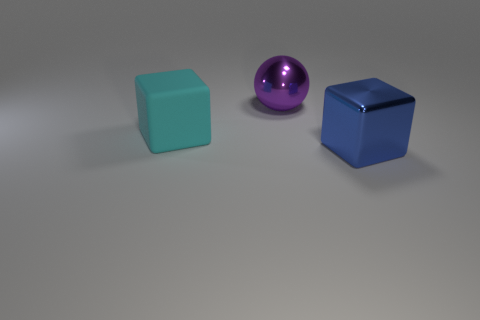There is a blue block that is made of the same material as the big sphere; what size is it?
Make the answer very short. Large. What material is the block to the right of the large cube behind the big shiny block in front of the large cyan rubber object?
Your answer should be compact. Metal. Is the number of large metallic blocks less than the number of green blocks?
Make the answer very short. No. Is the material of the purple ball the same as the large cyan cube?
Make the answer very short. No. There is a big metal thing right of the large ball; how many metal things are left of it?
Offer a terse response. 1. There is a block that is the same size as the cyan thing; what is its color?
Provide a succinct answer. Blue. What material is the block in front of the cyan rubber block?
Provide a succinct answer. Metal. There is a big object that is on the right side of the rubber object and in front of the purple sphere; what material is it?
Make the answer very short. Metal. What is the shape of the large cyan rubber thing?
Your answer should be very brief. Cube. How many large blue objects have the same shape as the big cyan thing?
Keep it short and to the point. 1. 